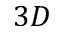<formula> <loc_0><loc_0><loc_500><loc_500>3 D</formula> 